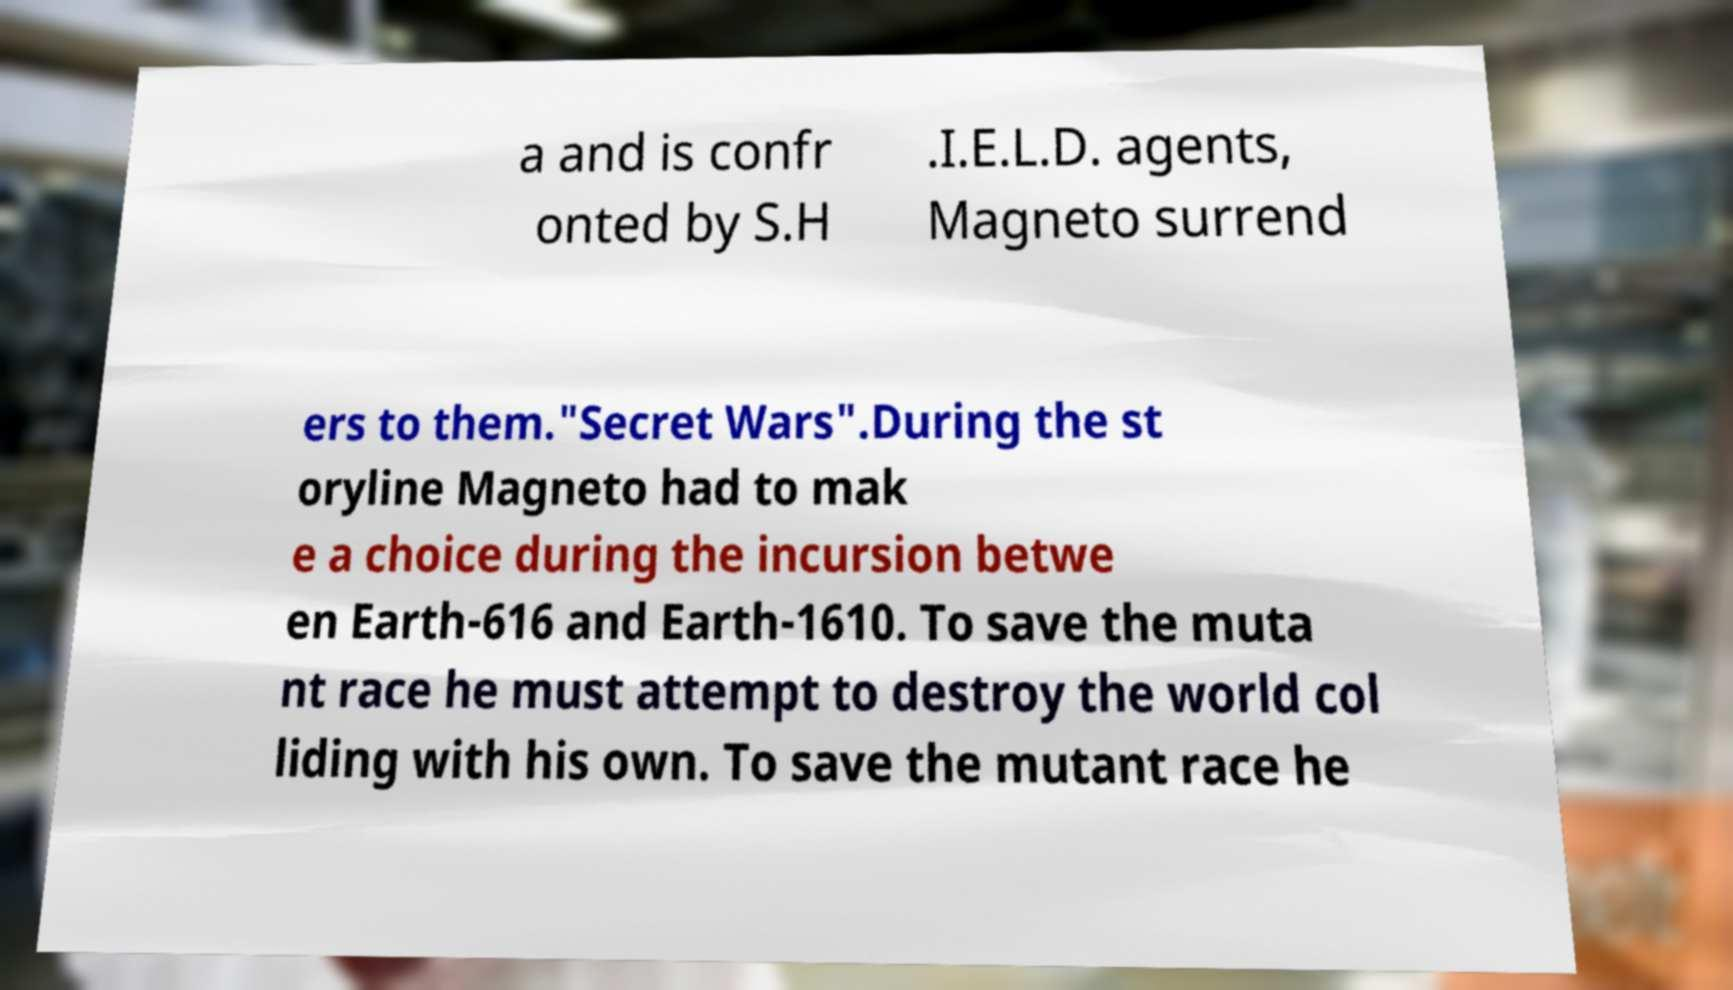I need the written content from this picture converted into text. Can you do that? a and is confr onted by S.H .I.E.L.D. agents, Magneto surrend ers to them."Secret Wars".During the st oryline Magneto had to mak e a choice during the incursion betwe en Earth-616 and Earth-1610. To save the muta nt race he must attempt to destroy the world col liding with his own. To save the mutant race he 